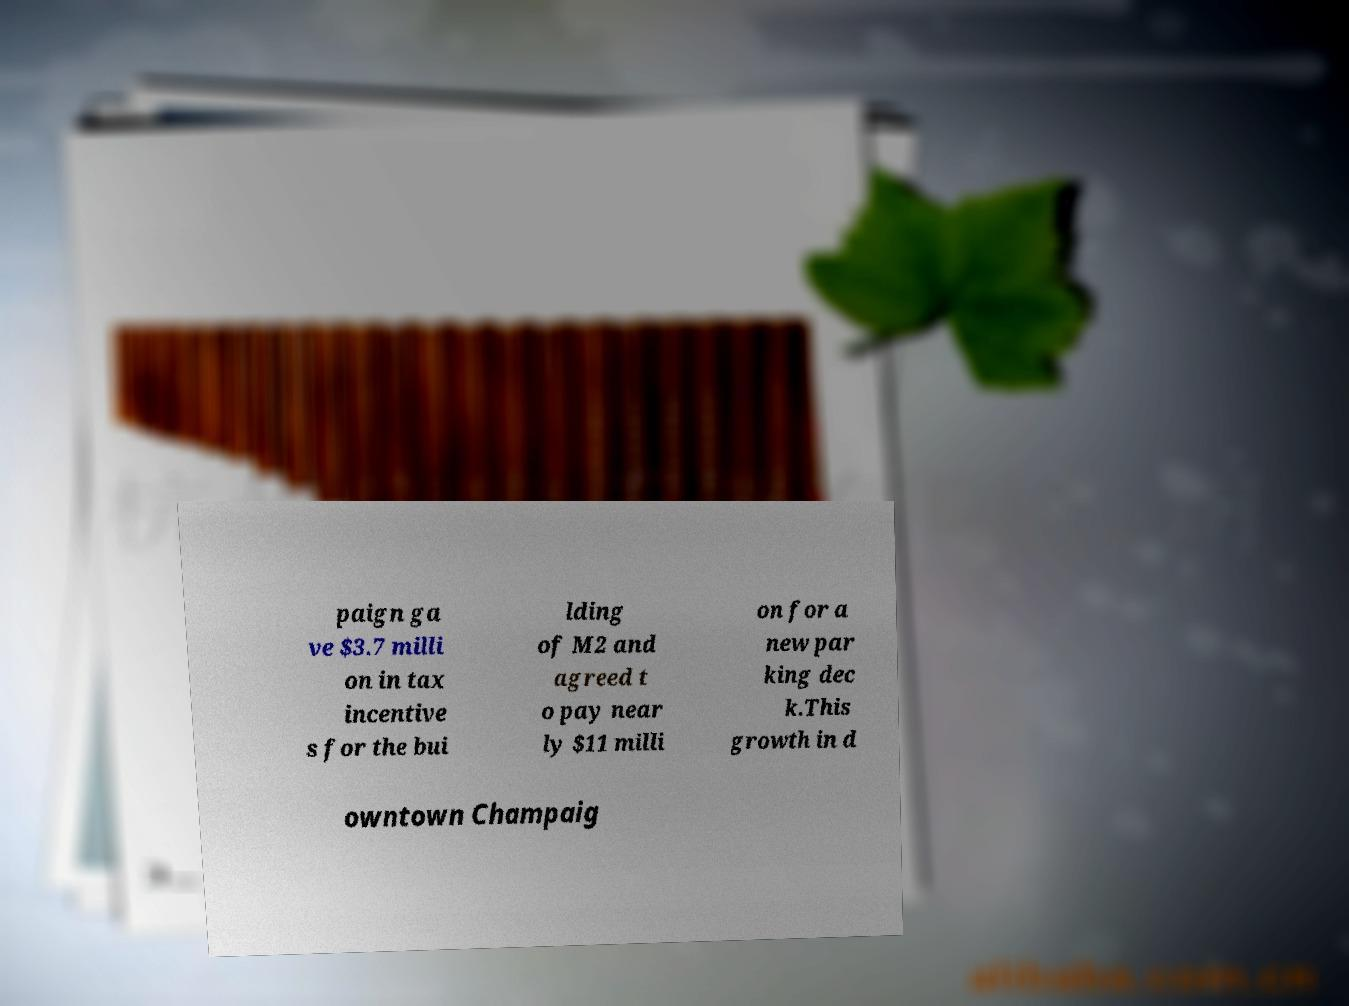Can you read and provide the text displayed in the image?This photo seems to have some interesting text. Can you extract and type it out for me? paign ga ve $3.7 milli on in tax incentive s for the bui lding of M2 and agreed t o pay near ly $11 milli on for a new par king dec k.This growth in d owntown Champaig 